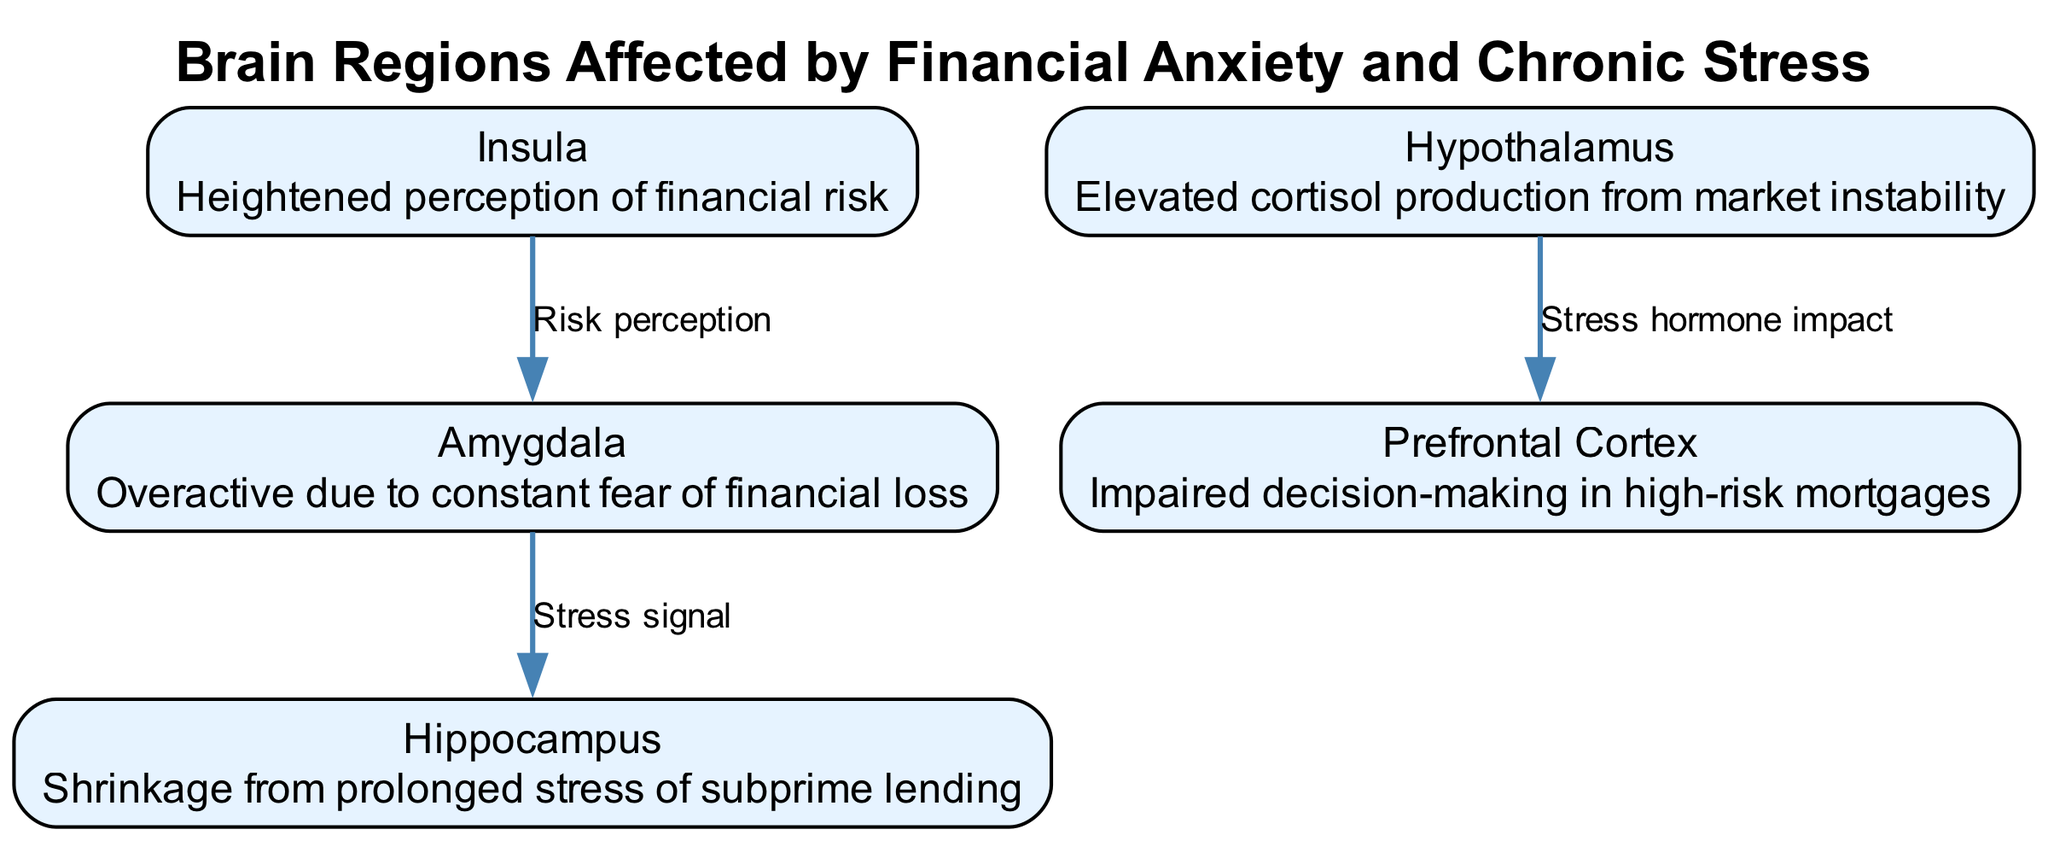What is the total number of nodes in the diagram? The diagram includes five distinct regions that are involved in the response to financial anxiety and chronic stress. Counting these nodes gives a total of five.
Answer: 5 Which node is described as being overactive due to constant fear of financial loss? The diagram explicitly states that the amygdala is the node that is overactive due to constant fear of financial loss. Thus, the answer is the amygdala.
Answer: amygdala What relationship does the hypothalamus have with the prefrontal cortex? The diagram indicates an edge from the hypothalamus to the prefrontal cortex labeled 'Stress hormone impact', indicating a direct relationship where stress hormones from the hypothalamus affect the prefrontal cortex.
Answer: Stress hormone impact How does the insula influence the amygdala? According to the diagram, there is an edge from the insula to the amygdala labeled 'Risk perception', implying that the insula influences the amygdala's response by shaping perceptions of financial risk.
Answer: Risk perception Which node is associated with shrinkage from prolonged stress of subprime lending? The hippocampus is specifically noted in the diagram for experiencing shrinkage due to the prolonged stress experienced as a result of subprime lending.
Answer: Hippocampus What effect does chronic stress have on decision-making in the context of mortgages? The prefrontal cortex is identified in the diagram as impaired in decision-making due to high-risk mortgages, linking chronic stress to poor financial decision-making.
Answer: Impaired decision-making Which brain region is affected by elevated cortisol production? The diagram illustrates that the hypothalamus is associated with elevated cortisol production, particularly connected to market instability.
Answer: Hypothalamus What is the link between the amygdala and the hippocampus in this context? The diagram depicts a connection labeled 'Stress signal' from the amygdala to the hippocampus, suggesting that stress signals trigger responses affecting the hippocampus.
Answer: Stress signal What psychological state is heightened in the insula as represented in the diagram? The diagram specifies that the insula has a heightened perception of financial risk, which indicates that this region is particularly attuned to financial anxieties.
Answer: Heightened perception of financial risk 